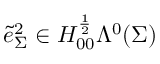<formula> <loc_0><loc_0><loc_500><loc_500>\tilde { e } _ { \Sigma } ^ { 2 } \in H _ { 0 0 } ^ { \frac { 1 } { 2 } } \Lambda ^ { 0 } ( \Sigma )</formula> 